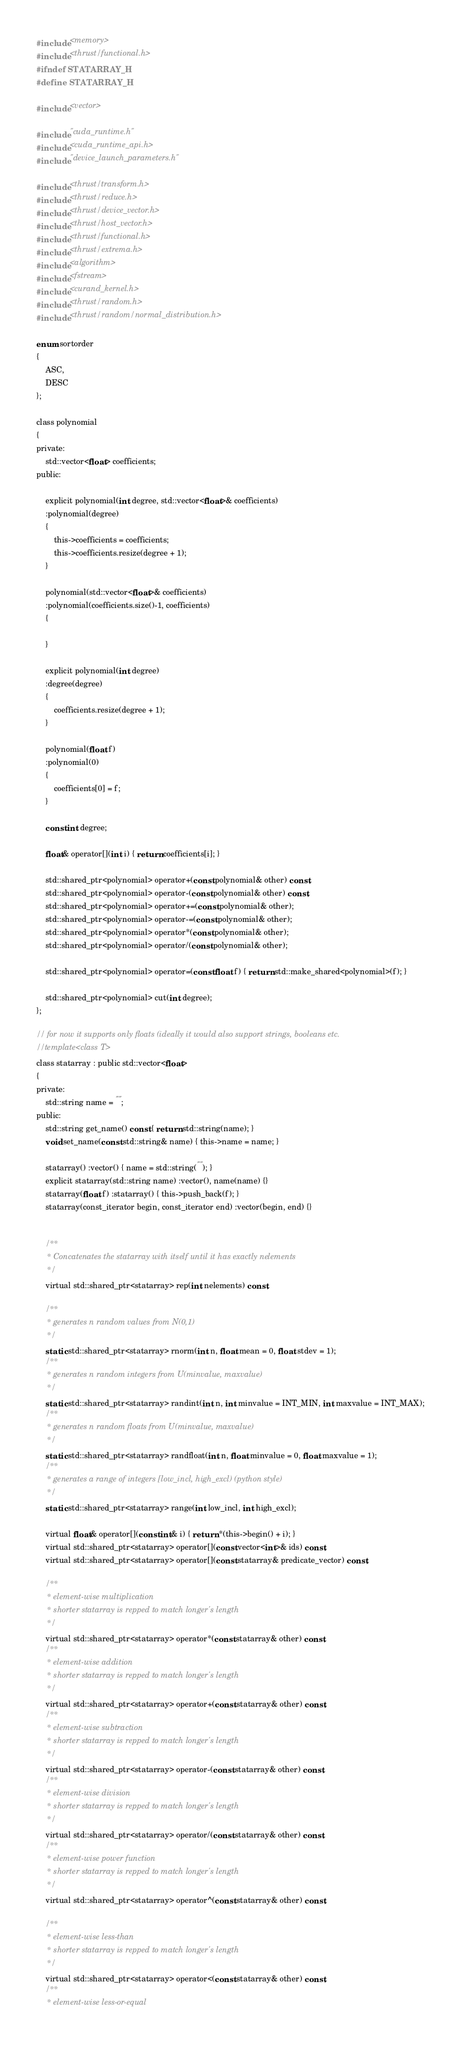Convert code to text. <code><loc_0><loc_0><loc_500><loc_500><_Cuda_>#include <memory>
#include <thrust/functional.h>
#ifndef STATARRAY_H
#define STATARRAY_H

#include <vector>

#include "cuda_runtime.h"
#include <cuda_runtime_api.h>
#include "device_launch_parameters.h"

#include <thrust/transform.h>
#include <thrust/reduce.h>
#include <thrust/device_vector.h>
#include <thrust/host_vector.h>
#include <thrust/functional.h>
#include <thrust/extrema.h>
#include <algorithm>
#include <fstream>
#include <curand_kernel.h>
#include <thrust/random.h>
#include <thrust/random/normal_distribution.h>

enum sortorder
{
	ASC,
	DESC
};

class polynomial
{
private:
	std::vector<float> coefficients;
public:

	explicit polynomial(int degree, std::vector<float>& coefficients) 
	:polynomial(degree)
	{
		this->coefficients = coefficients;
		this->coefficients.resize(degree + 1);
	}

	polynomial(std::vector<float>& coefficients)
	:polynomial(coefficients.size()-1, coefficients)
	{
		
	}

	explicit polynomial(int degree)
	:degree(degree)
	{
		coefficients.resize(degree + 1);
	}

	polynomial(float f)
	:polynomial(0)
	{
		coefficients[0] = f;
	}

	const int degree;

	float& operator[](int i) { return coefficients[i]; }

	std::shared_ptr<polynomial> operator+(const polynomial& other) const;
	std::shared_ptr<polynomial> operator-(const polynomial& other) const;
	std::shared_ptr<polynomial> operator+=(const polynomial& other);
	std::shared_ptr<polynomial> operator-=(const polynomial& other);
	std::shared_ptr<polynomial> operator*(const polynomial& other);
	std::shared_ptr<polynomial> operator/(const polynomial& other);

	std::shared_ptr<polynomial> operator=(const float f) { return std::make_shared<polynomial>(f); }

	std::shared_ptr<polynomial> cut(int degree);
};

// for now it supports only floats (ideally it would also support strings, booleans etc.
//template<class T>
class statarray : public std::vector<float>
{
private:
	std::string name = "";
public:
	std::string get_name() const { return std::string(name); }
	void set_name(const std::string& name) { this->name = name; }

	statarray() :vector() { name = std::string(""); }
	explicit statarray(std::string name) :vector(), name(name) {}
	statarray(float f) :statarray() { this->push_back(f); }
	statarray(const_iterator begin, const_iterator end) :vector(begin, end) {}


	/**
	 * Concatenates the statarray with itself until it has exactly nelements
	 */
	virtual std::shared_ptr<statarray> rep(int nelements) const;

	/**
	 * generates n random values from N(0,1)
	 */
	static std::shared_ptr<statarray> rnorm(int n, float mean = 0, float stdev = 1);
	/**
	 * generates n random integers from U(minvalue, maxvalue)
	 */
	static std::shared_ptr<statarray> randint(int n, int minvalue = INT_MIN, int maxvalue = INT_MAX);
	/**
	 * generates n random floats from U(minvalue, maxvalue)
	 */
	static std::shared_ptr<statarray> randfloat(int n, float minvalue = 0, float maxvalue = 1);
	/**
	 * generates a range of integers [low_incl, high_excl) (python style)
	 */
	static std::shared_ptr<statarray> range(int low_incl, int high_excl);

	virtual float& operator[](const int& i) { return *(this->begin() + i); }
	virtual std::shared_ptr<statarray> operator[](const vector<int>& ids) const;
	virtual std::shared_ptr<statarray> operator[](const statarray& predicate_vector) const;
 
	/**
	 * element-wise multiplication
	 * shorter statarray is repped to match longer's length
	 */
	virtual std::shared_ptr<statarray> operator*(const statarray& other) const;
	/**
	 * element-wise addition
	 * shorter statarray is repped to match longer's length
	 */
	virtual std::shared_ptr<statarray> operator+(const statarray& other) const;
	/**
	 * element-wise subtraction
	 * shorter statarray is repped to match longer's length
	 */
	virtual std::shared_ptr<statarray> operator-(const statarray& other) const;
	/**
	 * element-wise division
	 * shorter statarray is repped to match longer's length
	 */
	virtual std::shared_ptr<statarray> operator/(const statarray& other) const;
	/**
	 * element-wise power function
	 * shorter statarray is repped to match longer's length
	 */
	virtual std::shared_ptr<statarray> operator^(const statarray& other) const;
 
	/**
	 * element-wise less-than
	 * shorter statarray is repped to match longer's length
	 */
	virtual std::shared_ptr<statarray> operator<(const statarray& other) const;
	/**
	 * element-wise less-or-equal</code> 